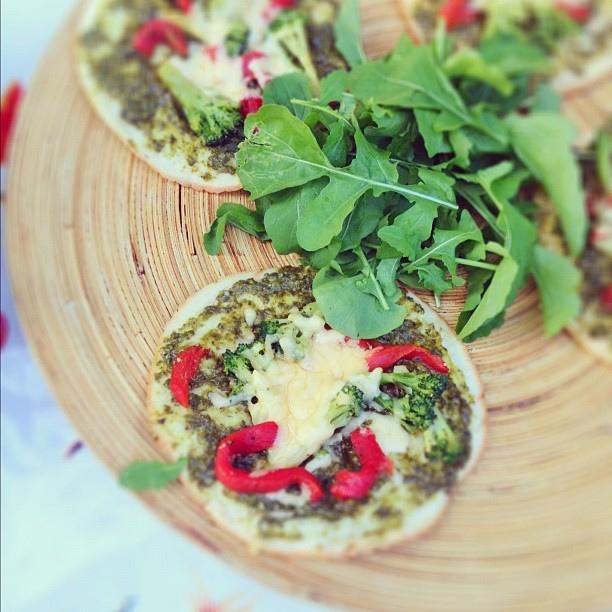What is on the dish?
Be succinct. Food. What kind of leaves are in the center?
Answer briefly. Parsley. Is this a healthy meal?
Give a very brief answer. Yes. 